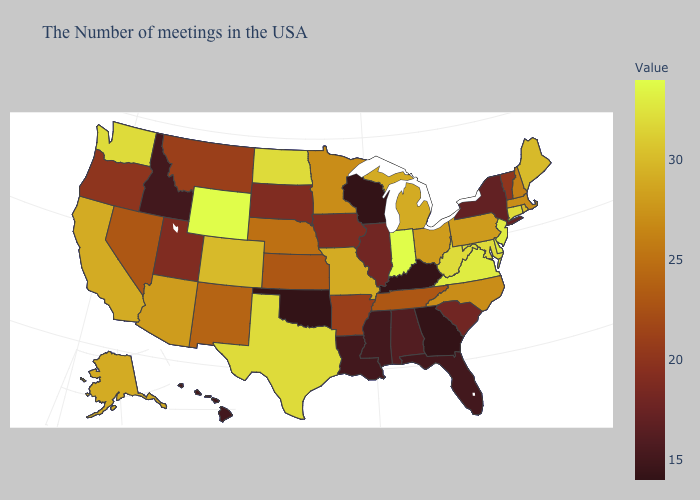Does California have a lower value than New Jersey?
Write a very short answer. Yes. Does the map have missing data?
Concise answer only. No. Does Hawaii have the lowest value in the West?
Be succinct. Yes. Does Georgia have the lowest value in the USA?
Quick response, please. Yes. 